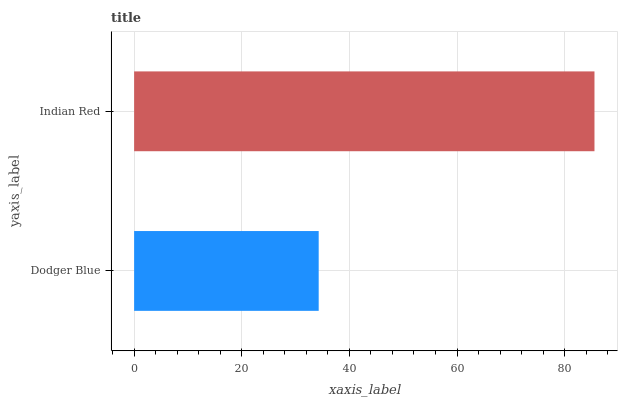Is Dodger Blue the minimum?
Answer yes or no. Yes. Is Indian Red the maximum?
Answer yes or no. Yes. Is Indian Red the minimum?
Answer yes or no. No. Is Indian Red greater than Dodger Blue?
Answer yes or no. Yes. Is Dodger Blue less than Indian Red?
Answer yes or no. Yes. Is Dodger Blue greater than Indian Red?
Answer yes or no. No. Is Indian Red less than Dodger Blue?
Answer yes or no. No. Is Indian Red the high median?
Answer yes or no. Yes. Is Dodger Blue the low median?
Answer yes or no. Yes. Is Dodger Blue the high median?
Answer yes or no. No. Is Indian Red the low median?
Answer yes or no. No. 